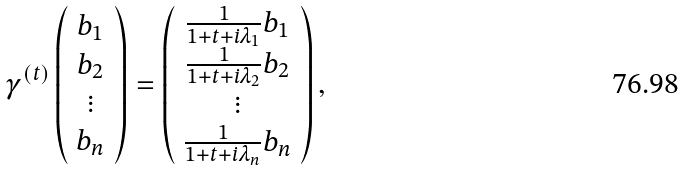<formula> <loc_0><loc_0><loc_500><loc_500>\gamma ^ { ( t ) } \left ( \begin{array} { c } b _ { 1 } \\ b _ { 2 } \\ \vdots \\ b _ { n } \end{array} \right ) = \left ( \begin{array} { c } \frac { 1 } { 1 + t + i \lambda _ { 1 } } b _ { 1 } \\ \frac { 1 } { 1 + t + i \lambda _ { 2 } } b _ { 2 } \\ \vdots \\ \frac { 1 } { 1 + t + i \lambda _ { n } } b _ { n } \end{array} \right ) ,</formula> 